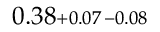Convert formula to latex. <formula><loc_0><loc_0><loc_500><loc_500>0 . 3 8 \substack { + 0 . 0 7 \, - 0 . 0 8 }</formula> 